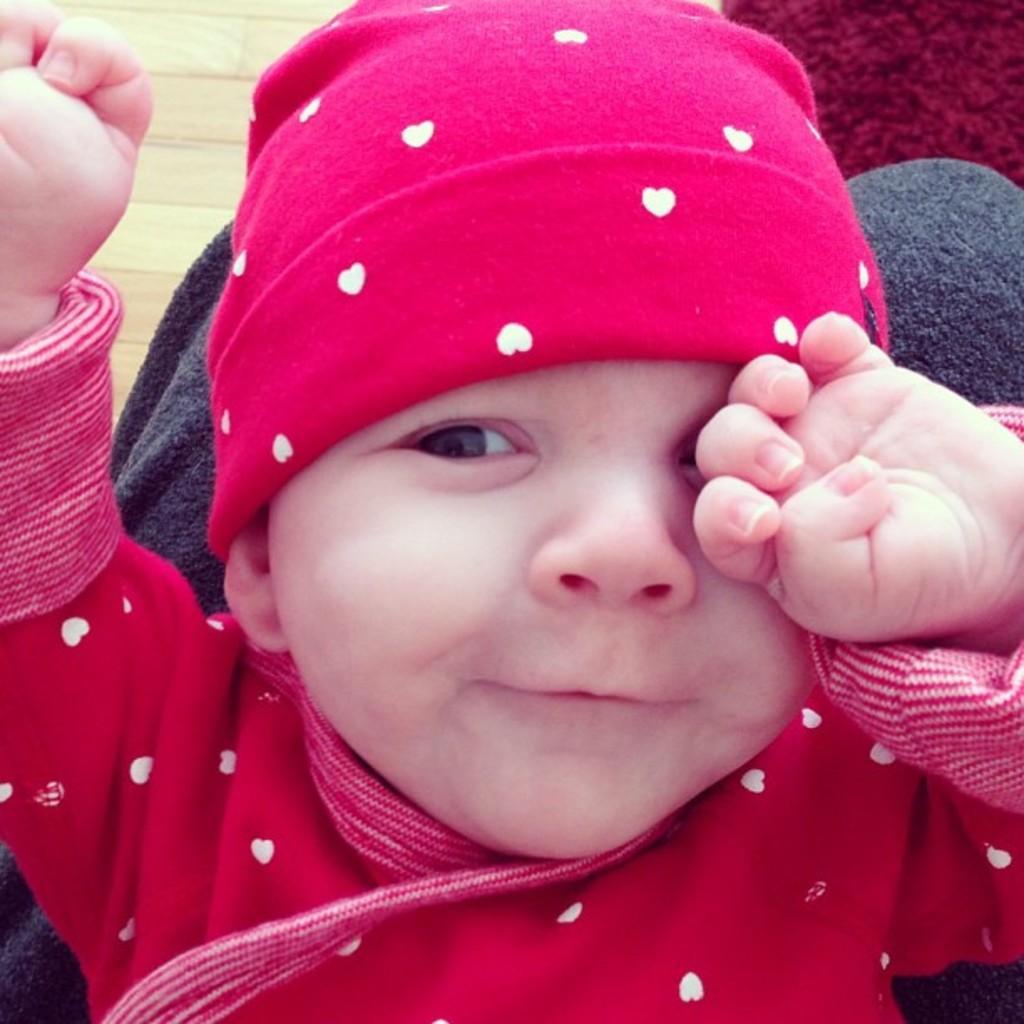In one or two sentences, can you explain what this image depicts? In the middle of the image we can see a baby and the baby is smiling. 